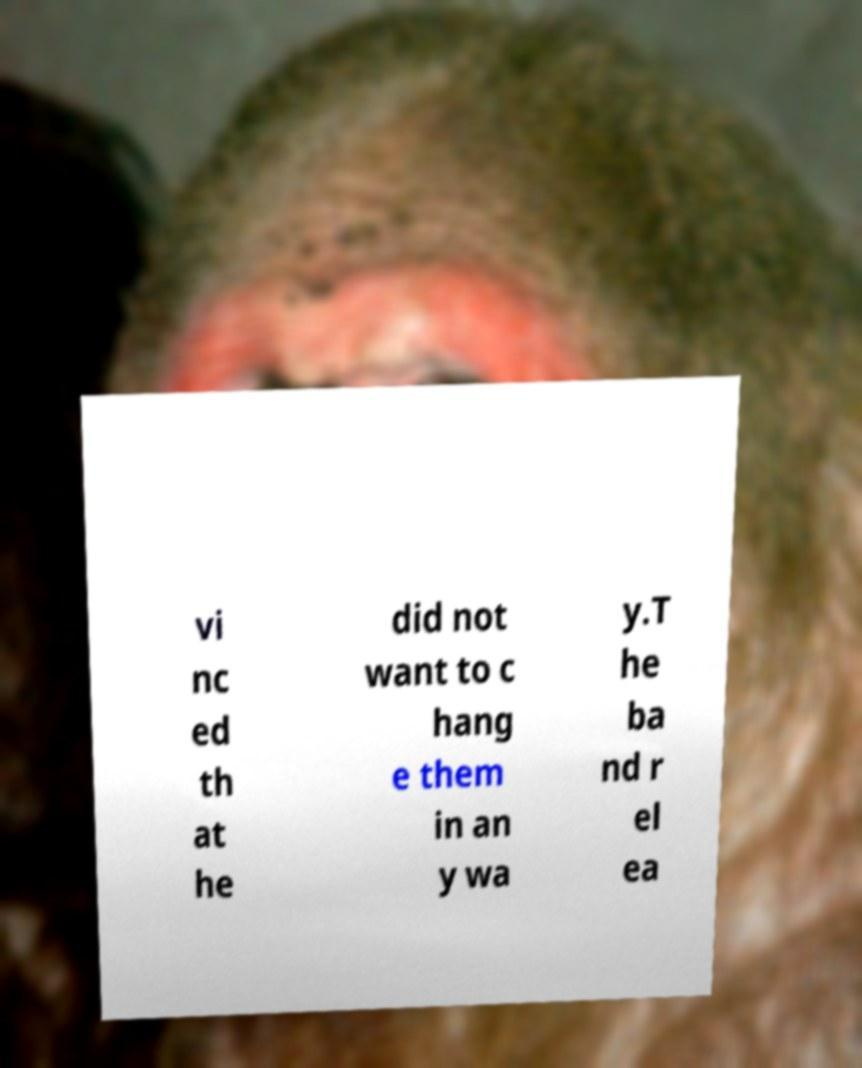There's text embedded in this image that I need extracted. Can you transcribe it verbatim? vi nc ed th at he did not want to c hang e them in an y wa y.T he ba nd r el ea 